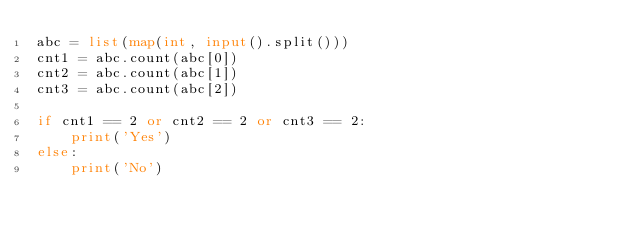Convert code to text. <code><loc_0><loc_0><loc_500><loc_500><_Python_>abc = list(map(int, input().split()))
cnt1 = abc.count(abc[0])
cnt2 = abc.count(abc[1])
cnt3 = abc.count(abc[2])

if cnt1 == 2 or cnt2 == 2 or cnt3 == 2:
    print('Yes')
else:
    print('No')</code> 